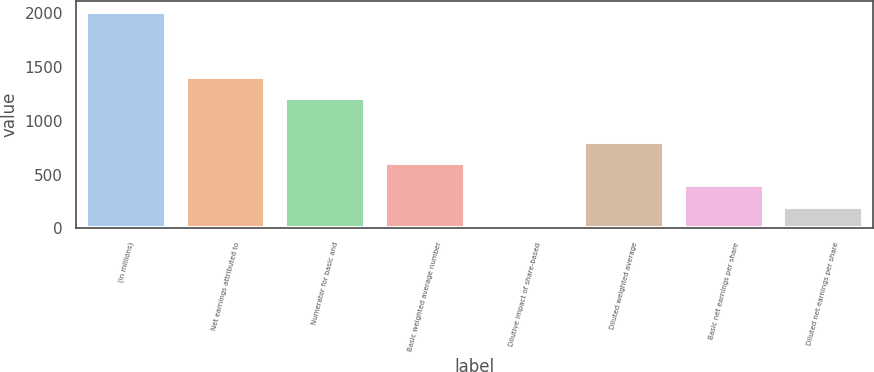Convert chart to OTSL. <chart><loc_0><loc_0><loc_500><loc_500><bar_chart><fcel>(in millions)<fcel>Net earnings attributed to<fcel>Numerator for basic and<fcel>Basic weighted average number<fcel>Dilutive impact of share-based<fcel>Diluted weighted average<fcel>Basic net earnings per share<fcel>Diluted net earnings per share<nl><fcel>2014<fcel>1410.25<fcel>1209<fcel>605.25<fcel>1.5<fcel>806.5<fcel>404<fcel>202.75<nl></chart> 